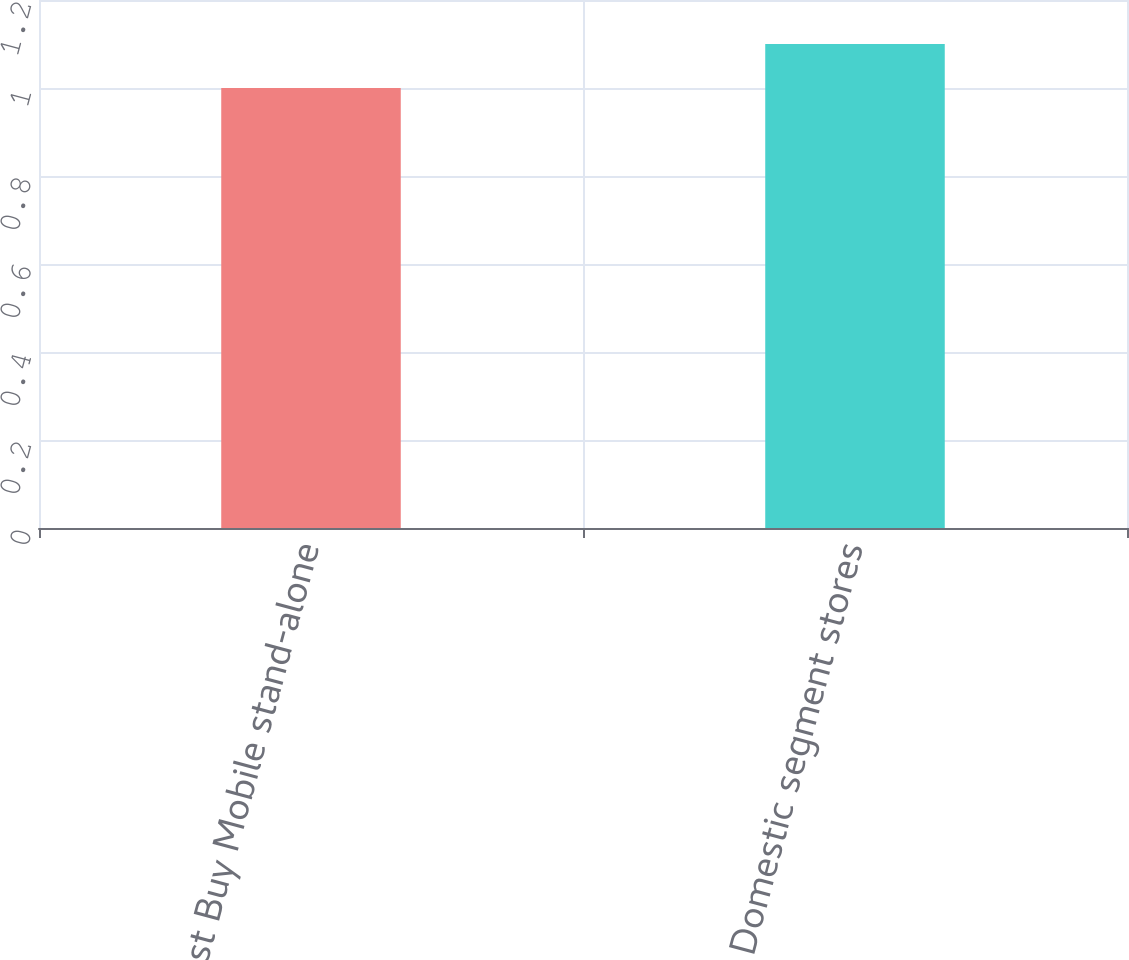<chart> <loc_0><loc_0><loc_500><loc_500><bar_chart><fcel>Best Buy Mobile stand-alone<fcel>Total Domestic segment stores<nl><fcel>1<fcel>1.1<nl></chart> 